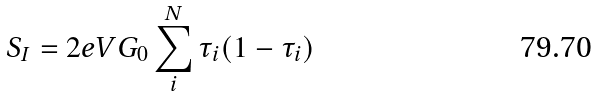<formula> <loc_0><loc_0><loc_500><loc_500>S _ { I } = 2 e V G _ { 0 } \sum _ { i } ^ { N } { \tau _ { i } ( 1 - \tau _ { i } ) }</formula> 